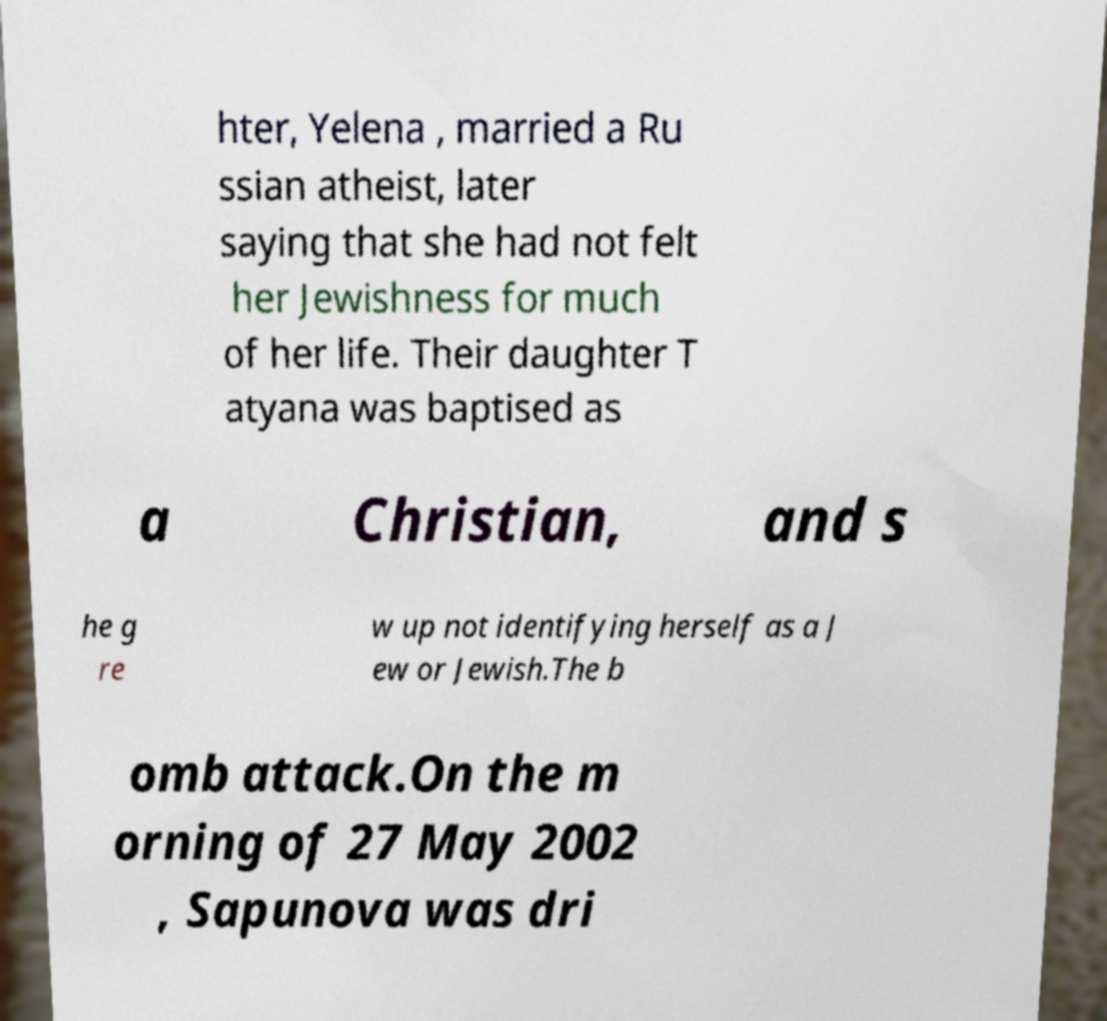Can you read and provide the text displayed in the image?This photo seems to have some interesting text. Can you extract and type it out for me? hter, Yelena , married a Ru ssian atheist, later saying that she had not felt her Jewishness for much of her life. Their daughter T atyana was baptised as a Christian, and s he g re w up not identifying herself as a J ew or Jewish.The b omb attack.On the m orning of 27 May 2002 , Sapunova was dri 